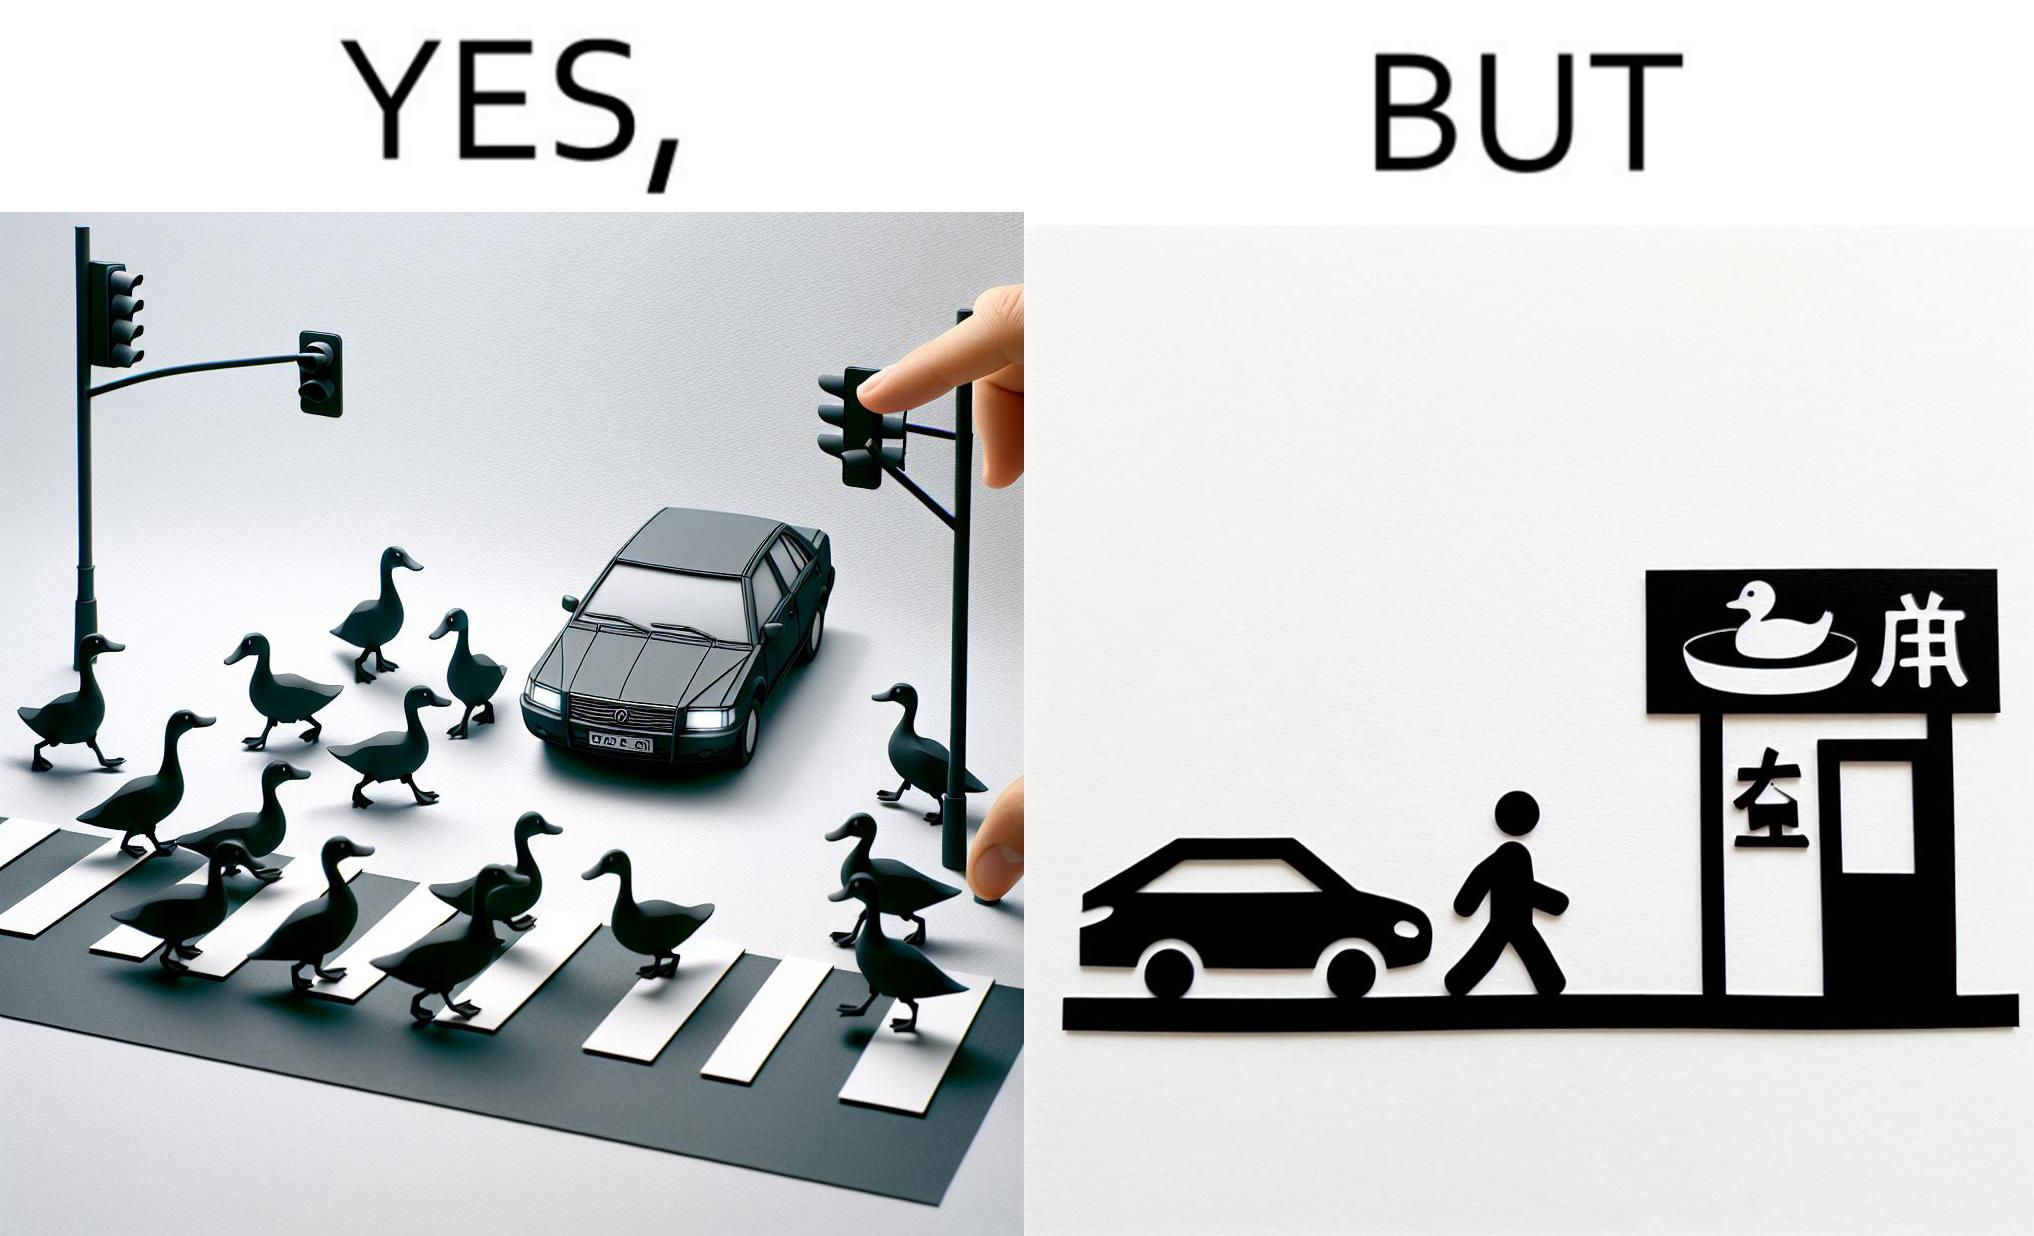Explain why this image is satirical. The images are ironic since they show how a man supposedly cares for ducks since he stops his vehicle to give way to queue of ducks allowing them to safely cross a road but on the other hand he goes to a peking duck shop to buy and eat similar ducks after having them killed 